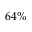Convert formula to latex. <formula><loc_0><loc_0><loc_500><loc_500>6 4 \%</formula> 